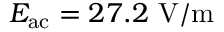<formula> <loc_0><loc_0><loc_500><loc_500>E _ { a c } = 2 7 . 2 V / m</formula> 